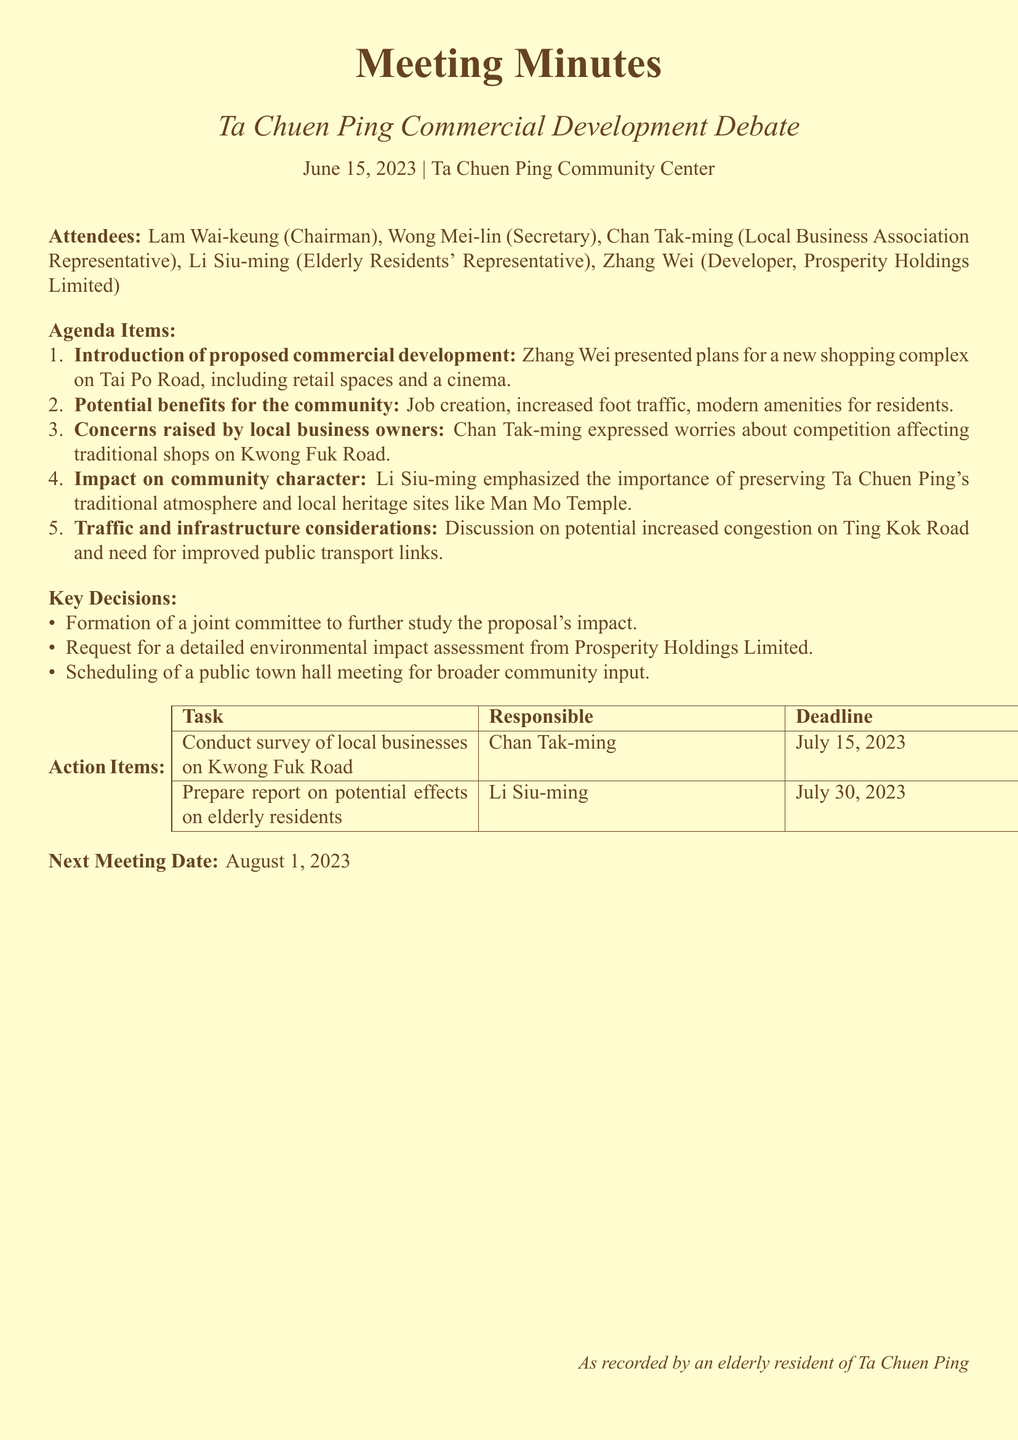What is the date of the meeting? The date of the meeting is explicitly stated in the document.
Answer: June 15, 2023 Who chaired the meeting? The document lists the attendees and specifies that Lam Wai-keung is the Chairman.
Answer: Lam Wai-keung What is the proposed new development? The document mentions the details of the proposed development clearly in the agenda items.
Answer: shopping complex on Tai Po Road What concern did Chan Tak-ming raise? Chan Tak-ming's concerns about competition are referenced in the agenda items.
Answer: competition affecting traditional shops What is to be scheduled for broader community input? The key decisions section indicates what will be scheduled for broader community involvement.
Answer: public town hall meeting What is one of the action items for Li Siu-ming? The action items provide a specific task assigned to Li Siu-ming.
Answer: Prepare report on potential effects on elderly residents When is the next meeting date? The next meeting date is specifically mentioned in the document.
Answer: August 1, 2023 What was emphasized by Li Siu-ming regarding community character? The details from the agenda discuss the importance of preserving local heritage.
Answer: preserving Ta Chuen Ping's traditional atmosphere 